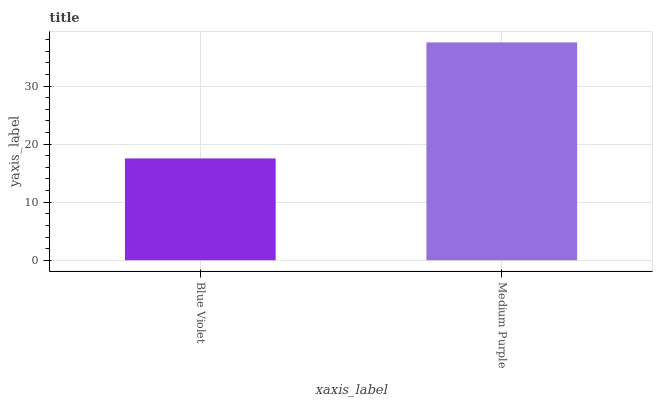Is Blue Violet the minimum?
Answer yes or no. Yes. Is Medium Purple the maximum?
Answer yes or no. Yes. Is Medium Purple the minimum?
Answer yes or no. No. Is Medium Purple greater than Blue Violet?
Answer yes or no. Yes. Is Blue Violet less than Medium Purple?
Answer yes or no. Yes. Is Blue Violet greater than Medium Purple?
Answer yes or no. No. Is Medium Purple less than Blue Violet?
Answer yes or no. No. Is Medium Purple the high median?
Answer yes or no. Yes. Is Blue Violet the low median?
Answer yes or no. Yes. Is Blue Violet the high median?
Answer yes or no. No. Is Medium Purple the low median?
Answer yes or no. No. 